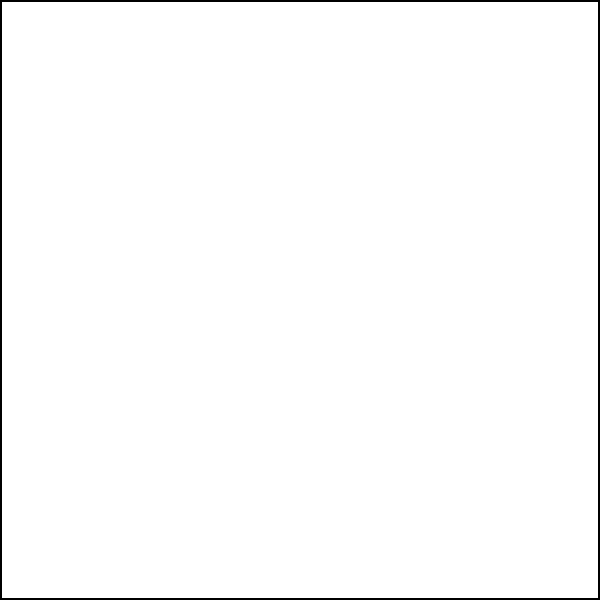In a machine learning model designed to identify fraudulent legal contracts, which feature extraction technique would be most effective in detecting the red circular markings shown in the sample contract image? To identify the most effective feature extraction technique for detecting the red circular markings in the sample contract image, we need to consider the following steps:

1. Analyze the image characteristics:
   - The image contains a contract outline with text lines and a signature line.
   - There are red circular markings indicating fraudulent elements.

2. Consider common feature extraction techniques:
   - Color-based features: Can detect the red color of the fraudulent markings.
   - Shape-based features: Can identify the circular shape of the markings.
   - Texture-based features: Not as relevant for this specific case.
   - Edge detection: Might detect the edges of the circles but not as effectively as other methods.

3. Evaluate the effectiveness of each technique:
   - Color-based features would be highly effective in this case because the fraudulent elements are distinctly red, contrasting with the black text and blue signature line.
   - Shape-based features would also be useful but might be less distinctive if other circular elements were present in genuine contracts.

4. Consider the context of legal contracts:
   - In real-world scenarios, fraudulent markings might vary in color and shape.
   - However, for this specific image, color is the most distinguishing feature.

5. Conclusion:
   - Color-based feature extraction would be the most effective technique for this particular case, as it can easily distinguish the red fraudulent markings from the rest of the contract elements.
Answer: Color-based feature extraction 